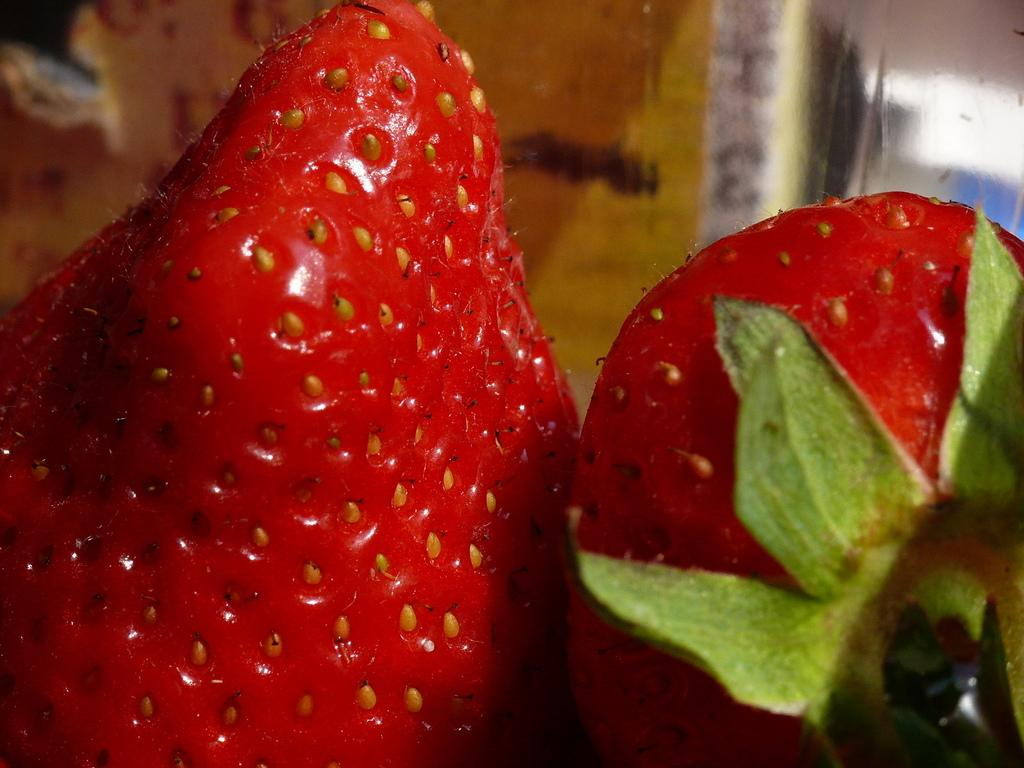What type of food is present in the image? There are two berries in the image. Can you describe the smell of the berries in the image? The image does not provide any information about the smell of the berries, as it is a visual medium. 